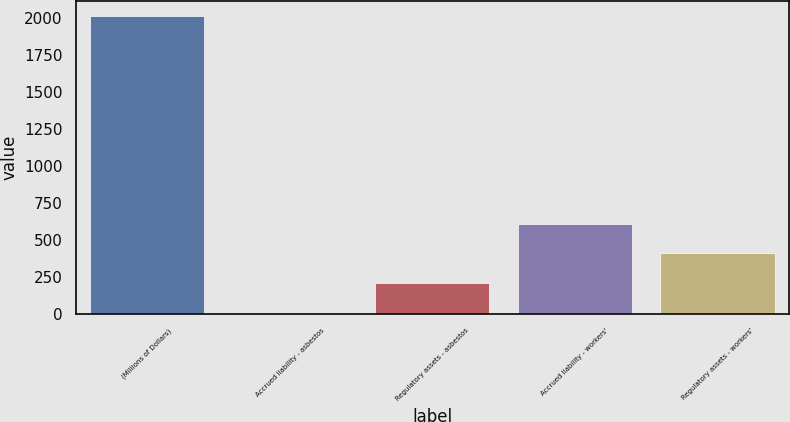Convert chart. <chart><loc_0><loc_0><loc_500><loc_500><bar_chart><fcel>(Millions of Dollars)<fcel>Accrued liability - asbestos<fcel>Regulatory assets - asbestos<fcel>Accrued liability - workers'<fcel>Regulatory assets - workers'<nl><fcel>2010<fcel>10<fcel>210<fcel>610<fcel>410<nl></chart> 